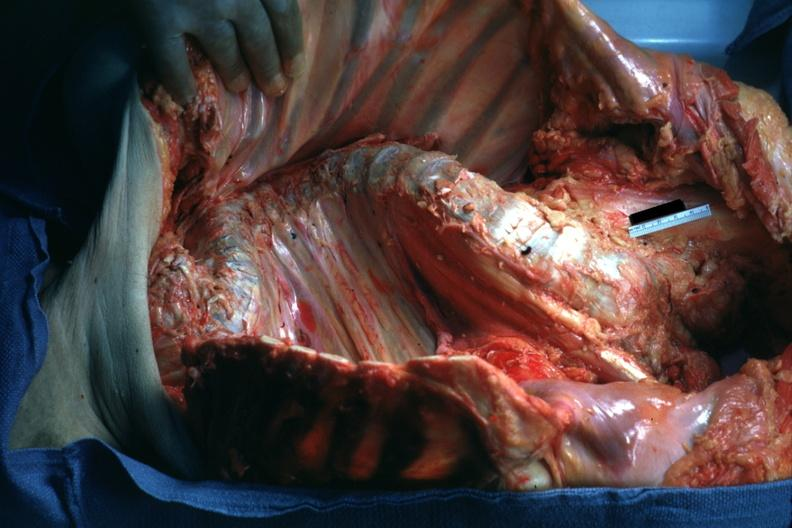s joints present?
Answer the question using a single word or phrase. Yes 